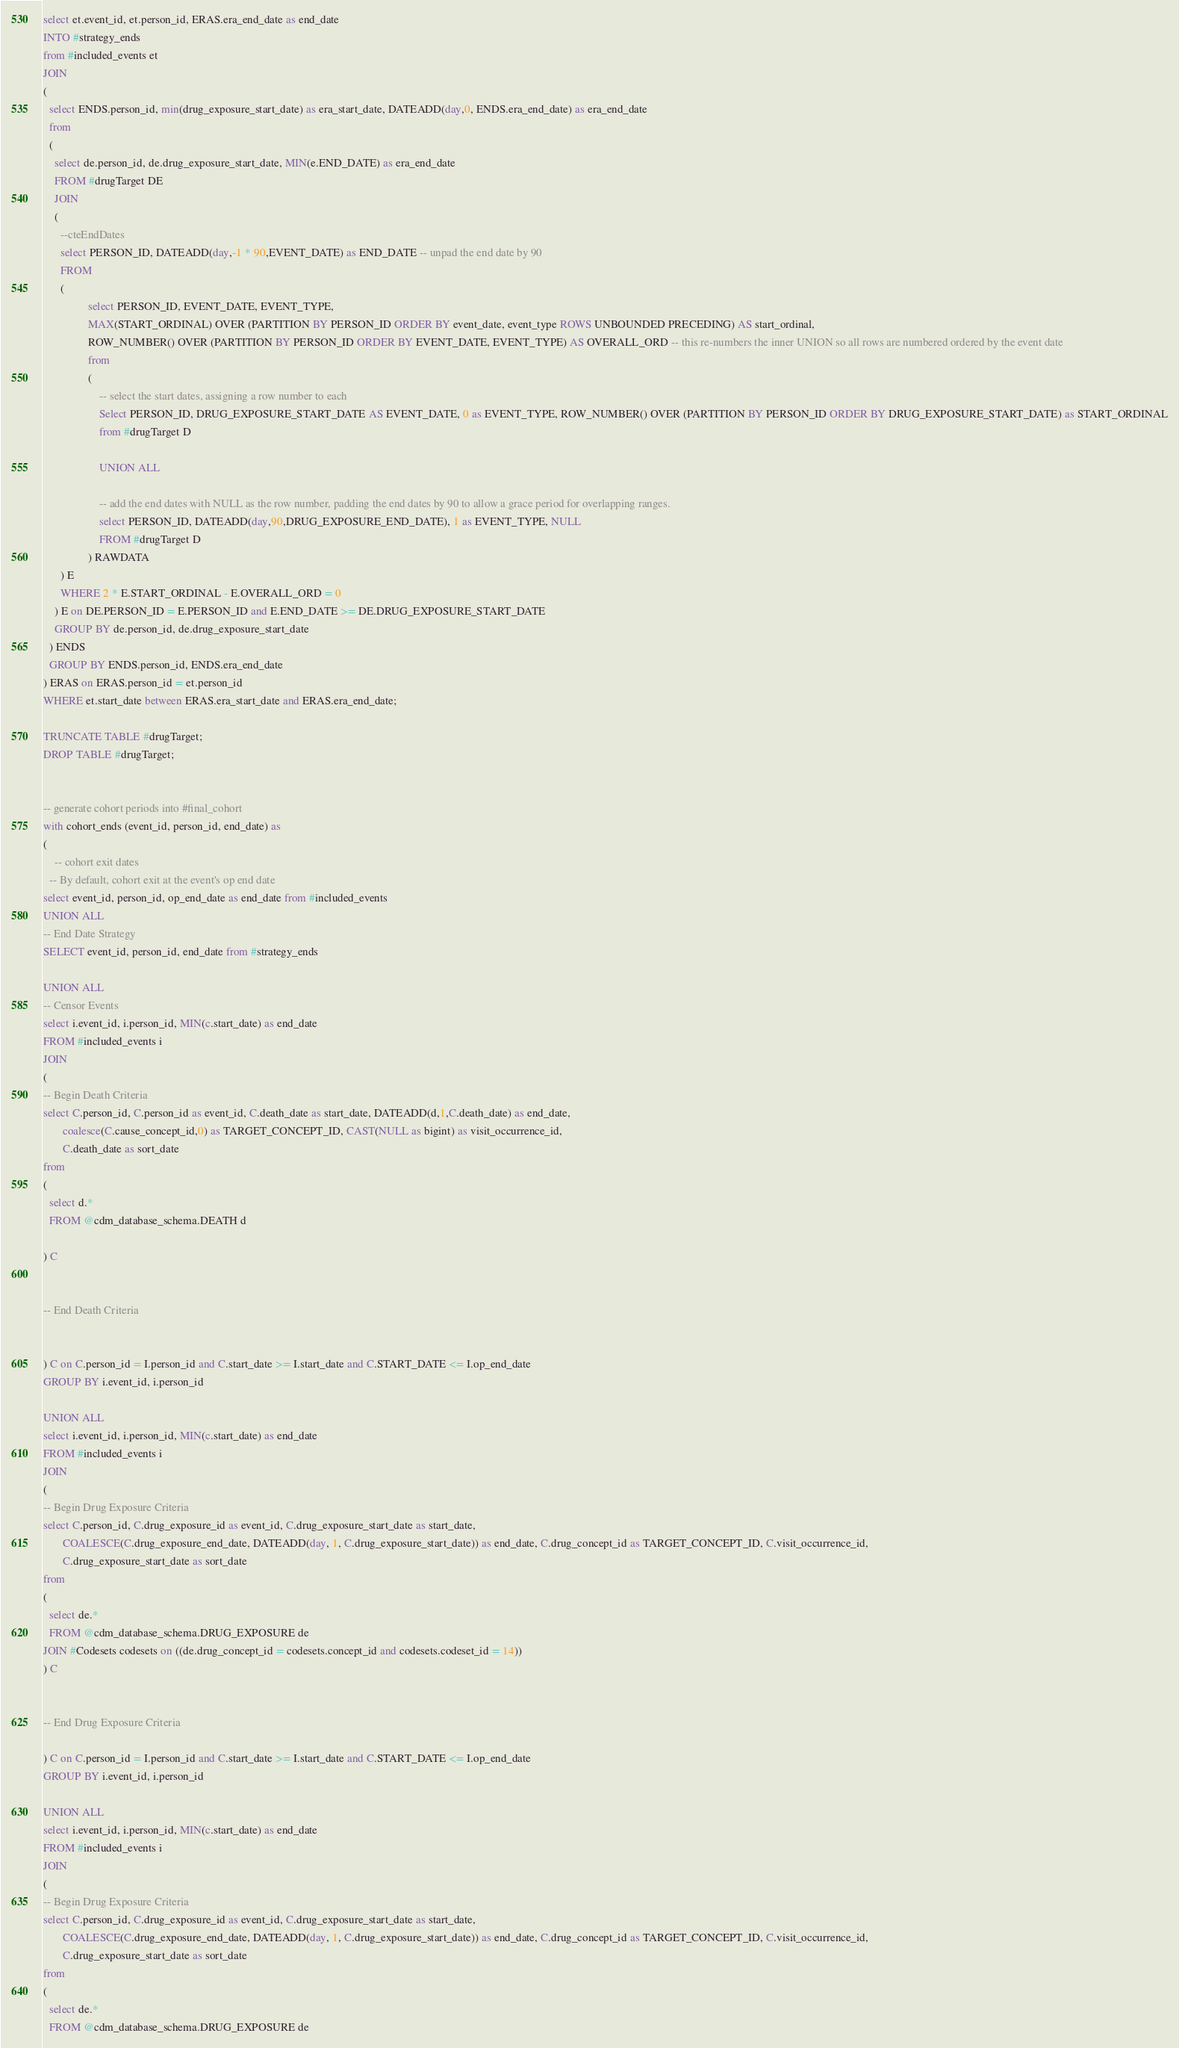<code> <loc_0><loc_0><loc_500><loc_500><_SQL_>select et.event_id, et.person_id, ERAS.era_end_date as end_date
INTO #strategy_ends
from #included_events et
JOIN 
(
  select ENDS.person_id, min(drug_exposure_start_date) as era_start_date, DATEADD(day,0, ENDS.era_end_date) as era_end_date
  from
  (
    select de.person_id, de.drug_exposure_start_date, MIN(e.END_DATE) as era_end_date
    FROM #drugTarget DE
    JOIN 
    (
      --cteEndDates
      select PERSON_ID, DATEADD(day,-1 * 90,EVENT_DATE) as END_DATE -- unpad the end date by 90
      FROM
      (
				select PERSON_ID, EVENT_DATE, EVENT_TYPE, 
				MAX(START_ORDINAL) OVER (PARTITION BY PERSON_ID ORDER BY event_date, event_type ROWS UNBOUNDED PRECEDING) AS start_ordinal,
				ROW_NUMBER() OVER (PARTITION BY PERSON_ID ORDER BY EVENT_DATE, EVENT_TYPE) AS OVERALL_ORD -- this re-numbers the inner UNION so all rows are numbered ordered by the event date
				from
				(
					-- select the start dates, assigning a row number to each
					Select PERSON_ID, DRUG_EXPOSURE_START_DATE AS EVENT_DATE, 0 as EVENT_TYPE, ROW_NUMBER() OVER (PARTITION BY PERSON_ID ORDER BY DRUG_EXPOSURE_START_DATE) as START_ORDINAL
					from #drugTarget D

					UNION ALL

					-- add the end dates with NULL as the row number, padding the end dates by 90 to allow a grace period for overlapping ranges.
					select PERSON_ID, DATEADD(day,90,DRUG_EXPOSURE_END_DATE), 1 as EVENT_TYPE, NULL
					FROM #drugTarget D
				) RAWDATA
      ) E
      WHERE 2 * E.START_ORDINAL - E.OVERALL_ORD = 0
    ) E on DE.PERSON_ID = E.PERSON_ID and E.END_DATE >= DE.DRUG_EXPOSURE_START_DATE
    GROUP BY de.person_id, de.drug_exposure_start_date
  ) ENDS
  GROUP BY ENDS.person_id, ENDS.era_end_date
) ERAS on ERAS.person_id = et.person_id 
WHERE et.start_date between ERAS.era_start_date and ERAS.era_end_date;

TRUNCATE TABLE #drugTarget;
DROP TABLE #drugTarget;


-- generate cohort periods into #final_cohort
with cohort_ends (event_id, person_id, end_date) as
(
	-- cohort exit dates
  -- By default, cohort exit at the event's op end date
select event_id, person_id, op_end_date as end_date from #included_events
UNION ALL
-- End Date Strategy
SELECT event_id, person_id, end_date from #strategy_ends

UNION ALL
-- Censor Events
select i.event_id, i.person_id, MIN(c.start_date) as end_date
FROM #included_events i
JOIN
(
-- Begin Death Criteria
select C.person_id, C.person_id as event_id, C.death_date as start_date, DATEADD(d,1,C.death_date) as end_date,
       coalesce(C.cause_concept_id,0) as TARGET_CONCEPT_ID, CAST(NULL as bigint) as visit_occurrence_id,
       C.death_date as sort_date
from 
(
  select d.*
  FROM @cdm_database_schema.DEATH d

) C


-- End Death Criteria


) C on C.person_id = I.person_id and C.start_date >= I.start_date and C.START_DATE <= I.op_end_date
GROUP BY i.event_id, i.person_id

UNION ALL
select i.event_id, i.person_id, MIN(c.start_date) as end_date
FROM #included_events i
JOIN
(
-- Begin Drug Exposure Criteria
select C.person_id, C.drug_exposure_id as event_id, C.drug_exposure_start_date as start_date,
       COALESCE(C.drug_exposure_end_date, DATEADD(day, 1, C.drug_exposure_start_date)) as end_date, C.drug_concept_id as TARGET_CONCEPT_ID, C.visit_occurrence_id,
       C.drug_exposure_start_date as sort_date
from 
(
  select de.* 
  FROM @cdm_database_schema.DRUG_EXPOSURE de
JOIN #Codesets codesets on ((de.drug_concept_id = codesets.concept_id and codesets.codeset_id = 14))
) C


-- End Drug Exposure Criteria

) C on C.person_id = I.person_id and C.start_date >= I.start_date and C.START_DATE <= I.op_end_date
GROUP BY i.event_id, i.person_id

UNION ALL
select i.event_id, i.person_id, MIN(c.start_date) as end_date
FROM #included_events i
JOIN
(
-- Begin Drug Exposure Criteria
select C.person_id, C.drug_exposure_id as event_id, C.drug_exposure_start_date as start_date,
       COALESCE(C.drug_exposure_end_date, DATEADD(day, 1, C.drug_exposure_start_date)) as end_date, C.drug_concept_id as TARGET_CONCEPT_ID, C.visit_occurrence_id,
       C.drug_exposure_start_date as sort_date
from 
(
  select de.* 
  FROM @cdm_database_schema.DRUG_EXPOSURE de</code> 